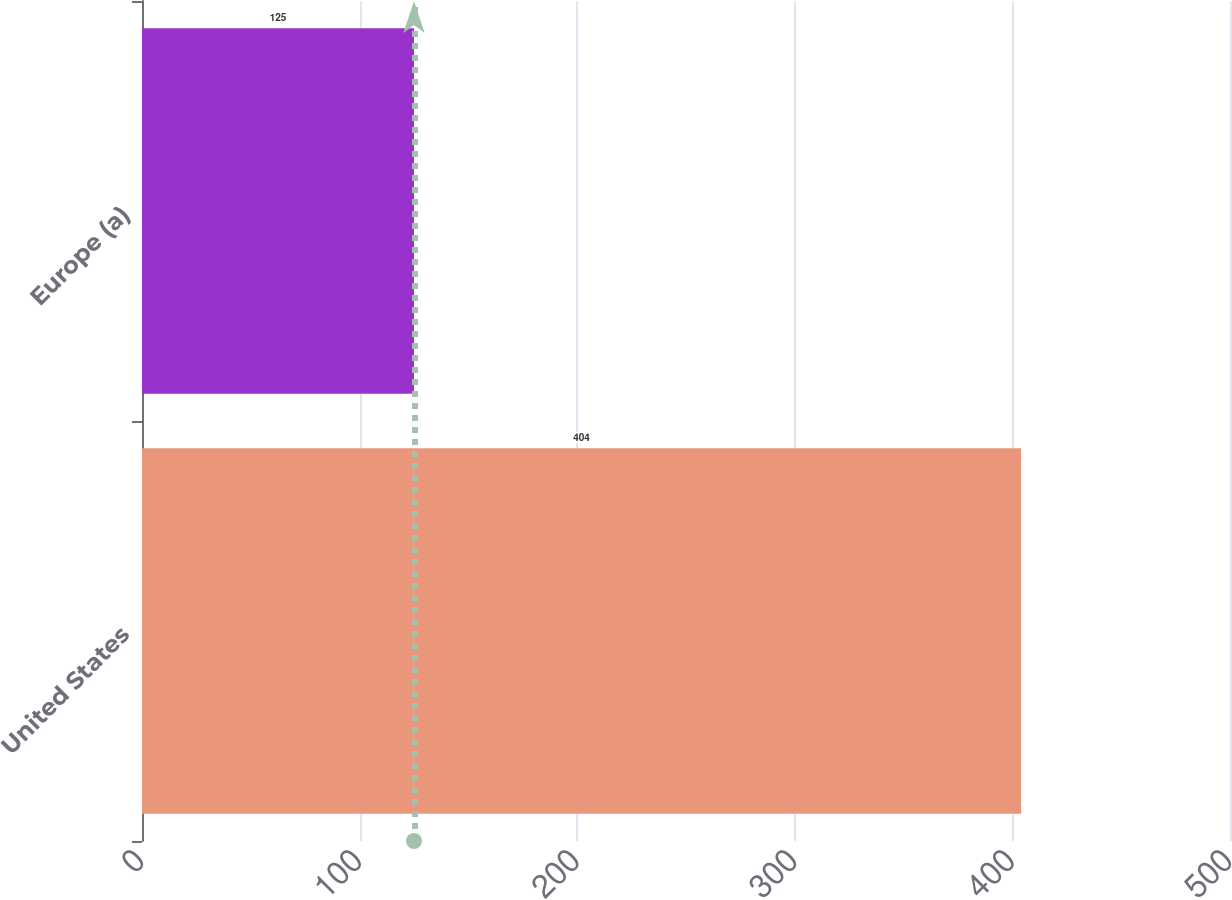<chart> <loc_0><loc_0><loc_500><loc_500><bar_chart><fcel>United States<fcel>Europe (a)<nl><fcel>404<fcel>125<nl></chart> 